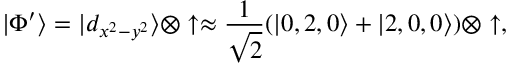<formula> <loc_0><loc_0><loc_500><loc_500>| \Phi ^ { \prime } \rangle = | d _ { x ^ { 2 } - y ^ { 2 } } \rangle \otimes \uparrow \approx \frac { 1 } { \sqrt { 2 } } ( | 0 , 2 , 0 \rangle + | 2 , 0 , 0 \rangle ) \otimes \uparrow ,</formula> 